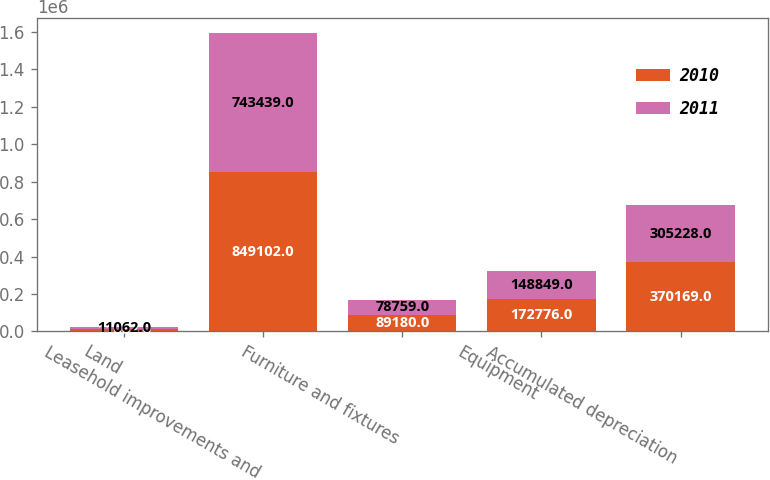Convert chart to OTSL. <chart><loc_0><loc_0><loc_500><loc_500><stacked_bar_chart><ecel><fcel>Land<fcel>Leasehold improvements and<fcel>Furniture and fixtures<fcel>Equipment<fcel>Accumulated depreciation<nl><fcel>2010<fcel>11062<fcel>849102<fcel>89180<fcel>172776<fcel>370169<nl><fcel>2011<fcel>11062<fcel>743439<fcel>78759<fcel>148849<fcel>305228<nl></chart> 